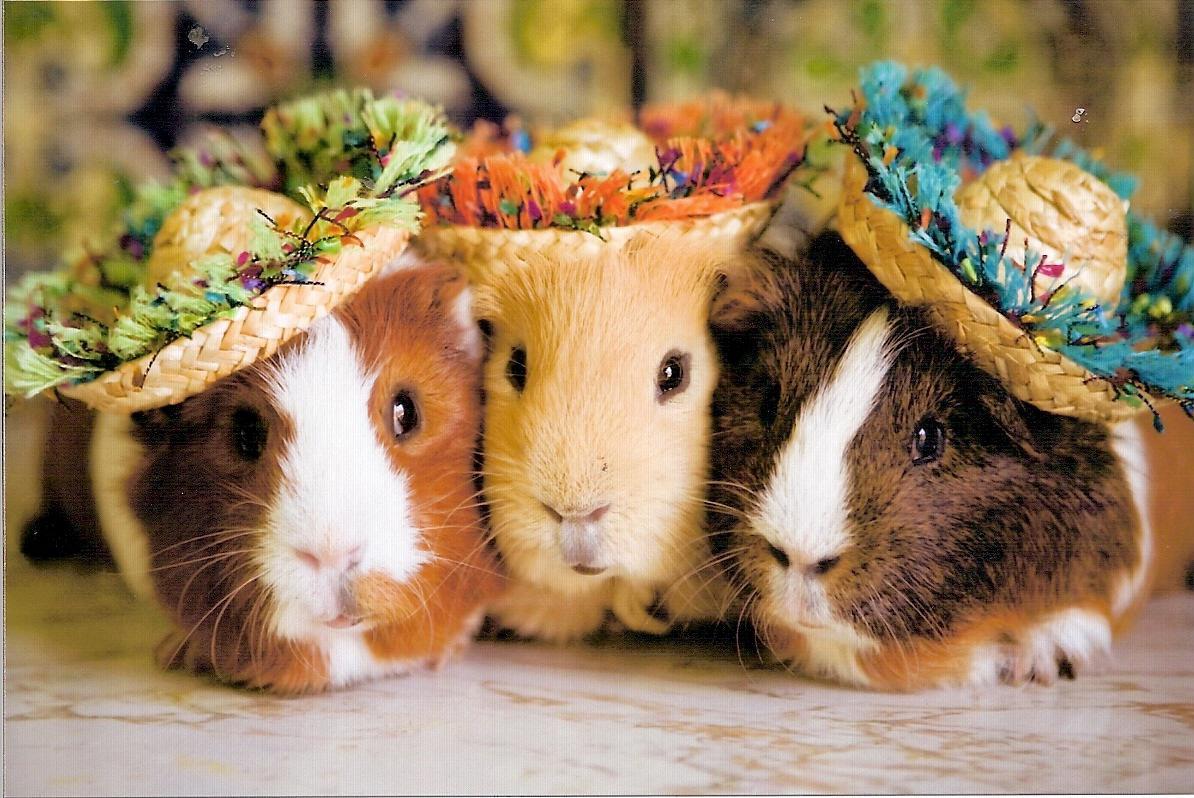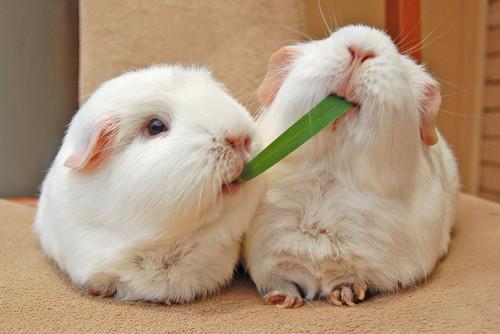The first image is the image on the left, the second image is the image on the right. Assess this claim about the two images: "There is at least one guinea pig with food in its mouth". Correct or not? Answer yes or no. Yes. The first image is the image on the left, the second image is the image on the right. Given the left and right images, does the statement "guinea pigs have food in their mouths" hold true? Answer yes or no. Yes. 